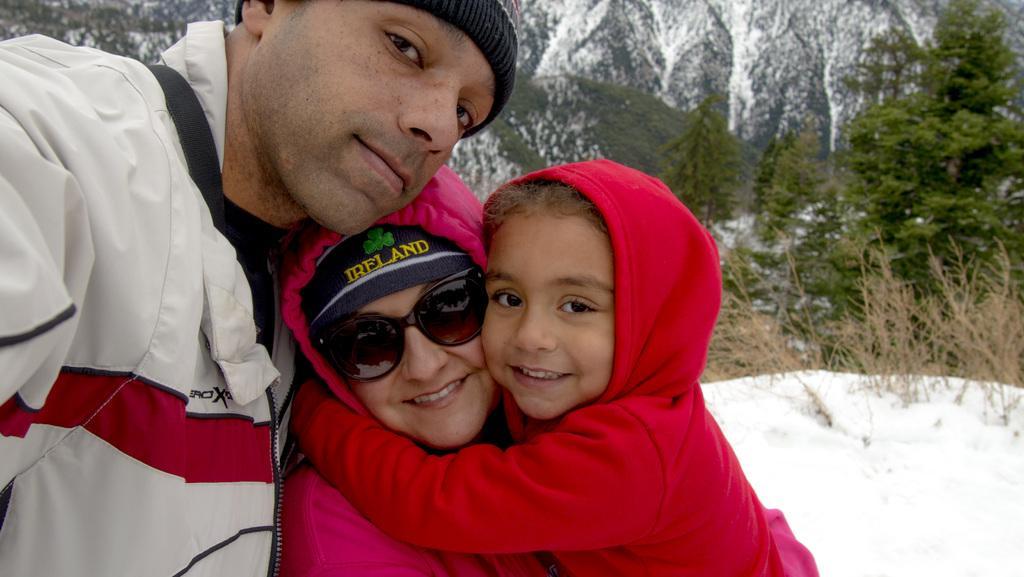Please provide a concise description of this image. In this picture we can see three people and in the background we can see snow, trees. 